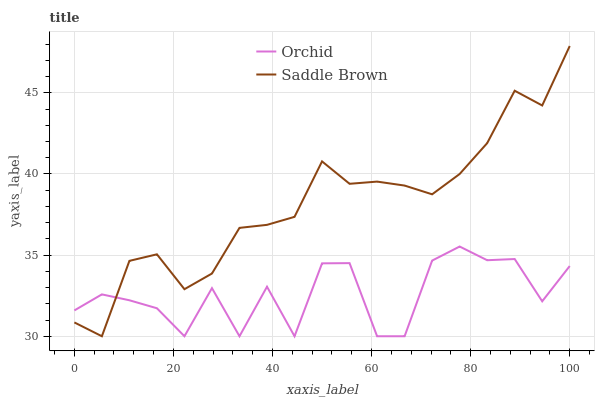Does Orchid have the minimum area under the curve?
Answer yes or no. Yes. Does Saddle Brown have the maximum area under the curve?
Answer yes or no. Yes. Does Orchid have the maximum area under the curve?
Answer yes or no. No. Is Saddle Brown the smoothest?
Answer yes or no. Yes. Is Orchid the roughest?
Answer yes or no. Yes. Is Orchid the smoothest?
Answer yes or no. No. Does Saddle Brown have the lowest value?
Answer yes or no. Yes. Does Saddle Brown have the highest value?
Answer yes or no. Yes. Does Orchid have the highest value?
Answer yes or no. No. Does Orchid intersect Saddle Brown?
Answer yes or no. Yes. Is Orchid less than Saddle Brown?
Answer yes or no. No. Is Orchid greater than Saddle Brown?
Answer yes or no. No. 